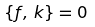Convert formula to latex. <formula><loc_0><loc_0><loc_500><loc_500>\{ f , \, k \} = 0</formula> 